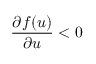Convert formula to latex. <formula><loc_0><loc_0><loc_500><loc_500>\frac { \partial f ( u ) } { \partial u } < 0</formula> 